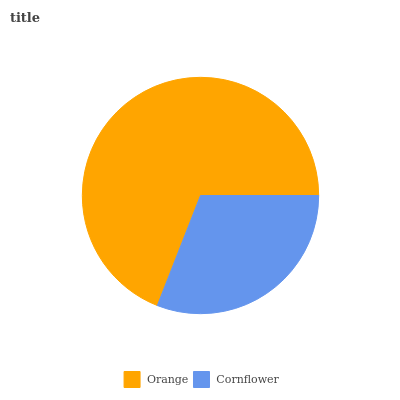Is Cornflower the minimum?
Answer yes or no. Yes. Is Orange the maximum?
Answer yes or no. Yes. Is Cornflower the maximum?
Answer yes or no. No. Is Orange greater than Cornflower?
Answer yes or no. Yes. Is Cornflower less than Orange?
Answer yes or no. Yes. Is Cornflower greater than Orange?
Answer yes or no. No. Is Orange less than Cornflower?
Answer yes or no. No. Is Orange the high median?
Answer yes or no. Yes. Is Cornflower the low median?
Answer yes or no. Yes. Is Cornflower the high median?
Answer yes or no. No. Is Orange the low median?
Answer yes or no. No. 